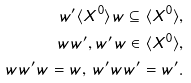<formula> <loc_0><loc_0><loc_500><loc_500>w ^ { \prime } \langle X ^ { 0 } \rangle w \subseteq \langle X ^ { 0 } \rangle , \\ w w ^ { \prime } , w ^ { \prime } w \in \langle X ^ { 0 } \rangle , \\ w w ^ { \prime } w = w , \, w ^ { \prime } w w ^ { \prime } = w ^ { \prime } .</formula> 